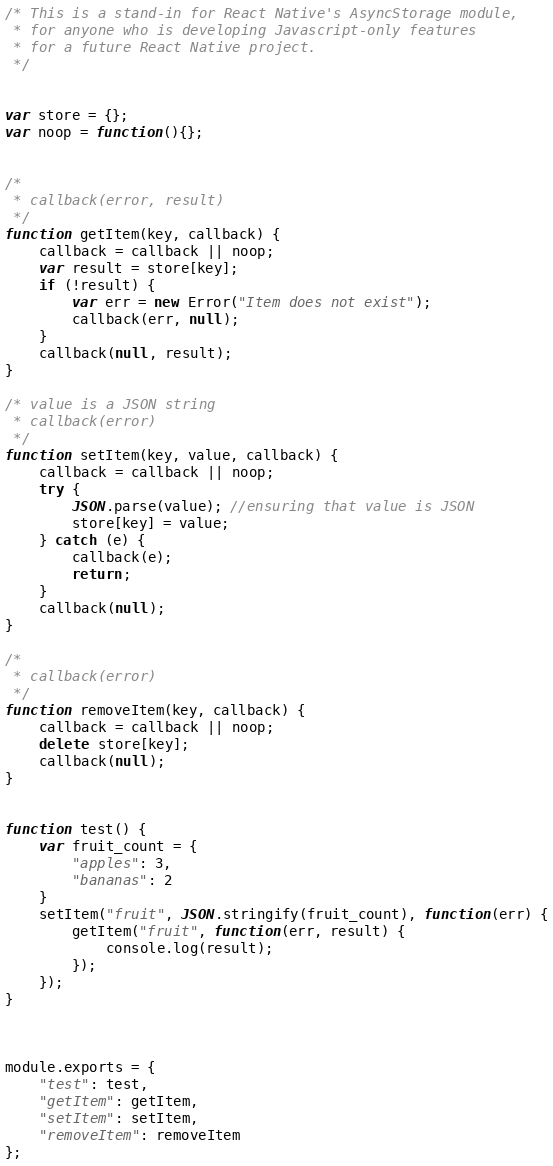<code> <loc_0><loc_0><loc_500><loc_500><_JavaScript_>/* This is a stand-in for React Native's AsyncStorage module,
 * for anyone who is developing Javascript-only features
 * for a future React Native project.
 */


var store = {};
var noop = function(){};


/* 
 * callback(error, result)
 */
function getItem(key, callback) {
	callback = callback || noop;
	var result = store[key];
	if (!result) {
		var err = new Error("Item does not exist");
		callback(err, null);
	}
	callback(null, result);
}

/* value is a JSON string
 * callback(error)
 */
function setItem(key, value, callback) {
	callback = callback || noop;
	try {
		JSON.parse(value); //ensuring that value is JSON
		store[key] = value;
	} catch (e) {
		callback(e);
		return;
	}
	callback(null);
}

/* 
 * callback(error)
 */
function removeItem(key, callback) {
	callback = callback || noop;
	delete store[key];
	callback(null);
}


function test() {
	var fruit_count = {
		"apples": 3,
		"bananas": 2
	}
	setItem("fruit", JSON.stringify(fruit_count), function(err) {
		getItem("fruit", function(err, result) {
			console.log(result);
		});
	});
}



module.exports = {
	"test": test,
	"getItem": getItem,
	"setItem": setItem,
	"removeItem": removeItem
};



</code> 